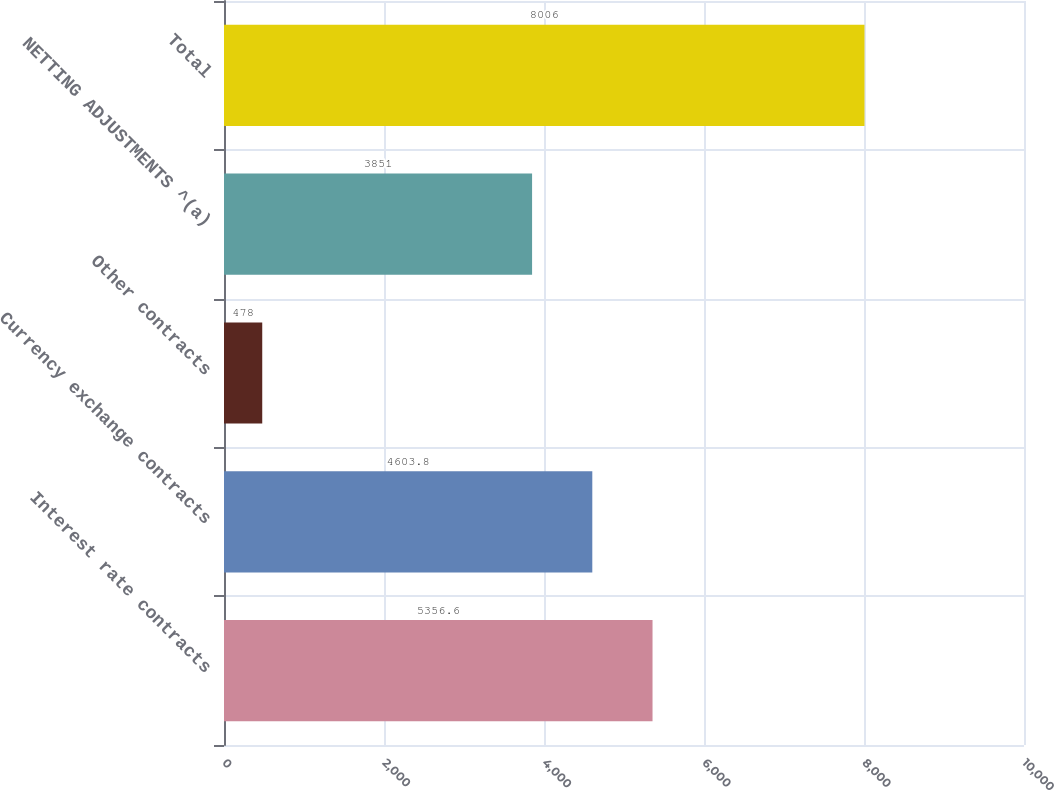Convert chart. <chart><loc_0><loc_0><loc_500><loc_500><bar_chart><fcel>Interest rate contracts<fcel>Currency exchange contracts<fcel>Other contracts<fcel>NETTING ADJUSTMENTS ^(a)<fcel>Total<nl><fcel>5356.6<fcel>4603.8<fcel>478<fcel>3851<fcel>8006<nl></chart> 